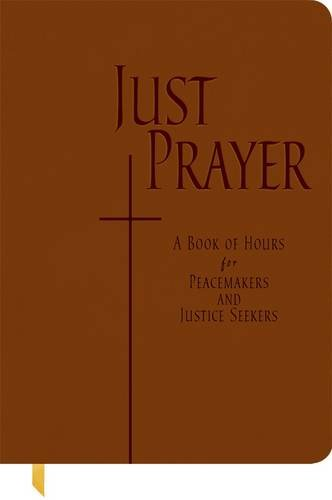How can this book be used in daily spiritual practices? This book can be used as a daily prayer guide, with structured prayer hours that align spiritual practice with working towards peace and justice in the community. 